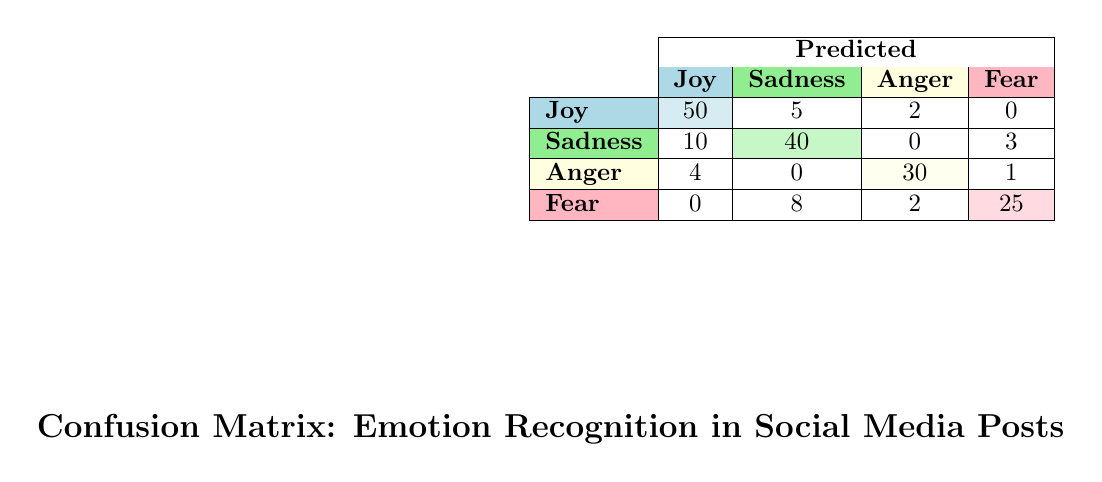What number of instances were correctly identified as "Joy"? The table shows that 50 instances of "Joy" were correctly predicted as "Joy" (the value in the first row and first column).
Answer: 50 How many instances were incorrectly predicted as "Sadness" when the actual emotion was "Joy"? Looking at the first row, the count for "Joy" predicted as "Sadness" is 5; this data point directly answers the question.
Answer: 5 What is the total number of instances predicted as "Fear"? To find this, we add the counts in the "Fear" column: 25 (Fear as Fear) + 8 (Sadness as Fear) + 2 (Anger as Fear) = 35.
Answer: 35 Did the algorithm perform best in recognizing "Anger"? Evaluating the diagonal of the confusion matrix for accuracy, "Anger" has 30 correctly predicted instances, while "Joy", "Sadness", and "Fear" have 50, 40, and 25 respectively. Thus, it did not perform best in recognizing "Anger."
Answer: No What percentage of actual "Sadness" instances were misclassified into "Joy"? The actual instances of "Sadness" total 53 (40 correct + 10 misclassified as Joy + 3 as Fear). The number of instances misclassified into "Joy" is 10. The percentage is (10/53) * 100 ≈ 18.87%.
Answer: Approximately 18.87% Which type of emotion had the second highest correct predictions? Reviewing the diagonal values: Joy = 50, Sadness = 40, Anger = 30, Fear = 25. "Sadness" has the second-highest correct predictions.
Answer: Sadness How many total instances were predicted as "Anger"? Adding the counts in the "Anger" column gives us: 30 (correctly predicted) + 4 (Joy as Anger) + 1 (Fear as Anger) = 35.
Answer: 35 What is the overall accuracy of the emotion recognition algorithm across all emotions? The overall accuracy is calculated by dividing the number of correctly predicted instances by the total instances. Correct predictions are 50 (Joy) + 40 (Sadness) + 30 (Anger) + 25 (Fear) = 145. The total instances are: 50 + 5 + 2 + 10 + 40 + 3 + 30 + 4 + 1 + 25 + 8 + 2 = 180. Thus, the accuracy is 145/180 ≈ 0.8056 or 80.56%.
Answer: Approximately 80.56% 